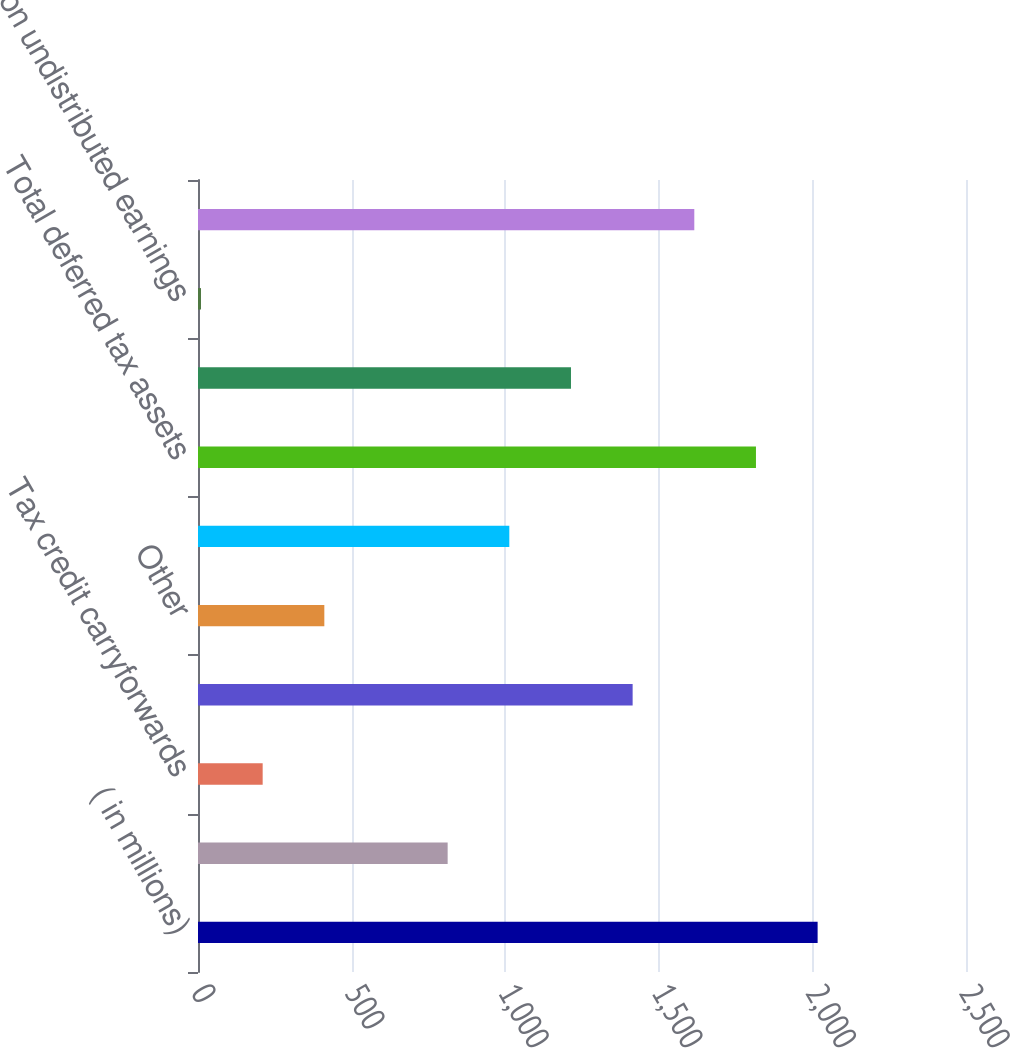<chart> <loc_0><loc_0><loc_500><loc_500><bar_chart><fcel>( in millions)<fcel>Net operating loss<fcel>Tax credit carryforwards<fcel>Pension and deferred<fcel>Other<fcel>Valuation allowance<fcel>Total deferred tax assets<fcel>Accelerated depreciation<fcel>Tax on undistributed earnings<fcel>Total deferred tax liabilities<nl><fcel>2017<fcel>812.68<fcel>210.52<fcel>1414.84<fcel>411.24<fcel>1013.4<fcel>1816.28<fcel>1214.12<fcel>9.8<fcel>1615.56<nl></chart> 